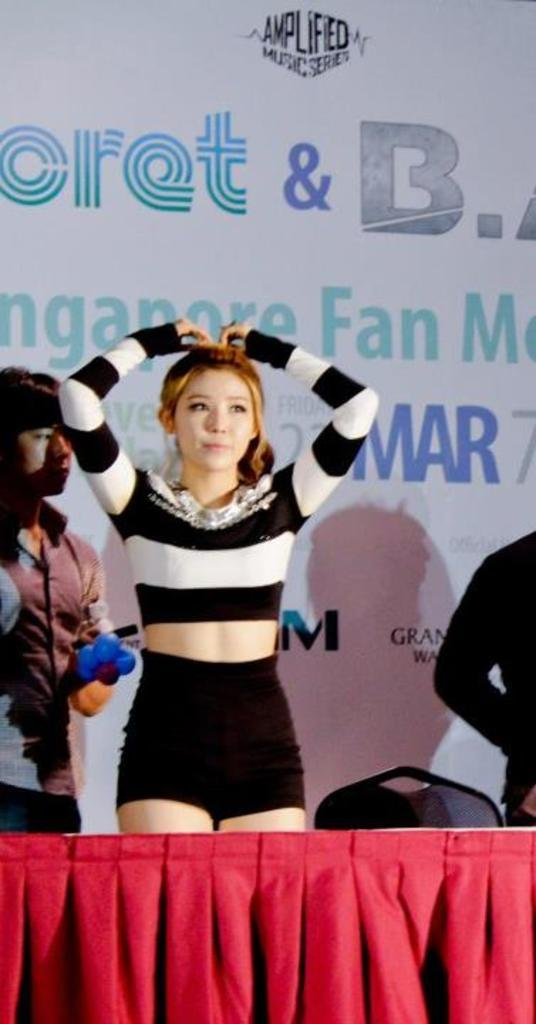<image>
Share a concise interpretation of the image provided. A girl stands in front of sign at an Amplified Music Services event. 